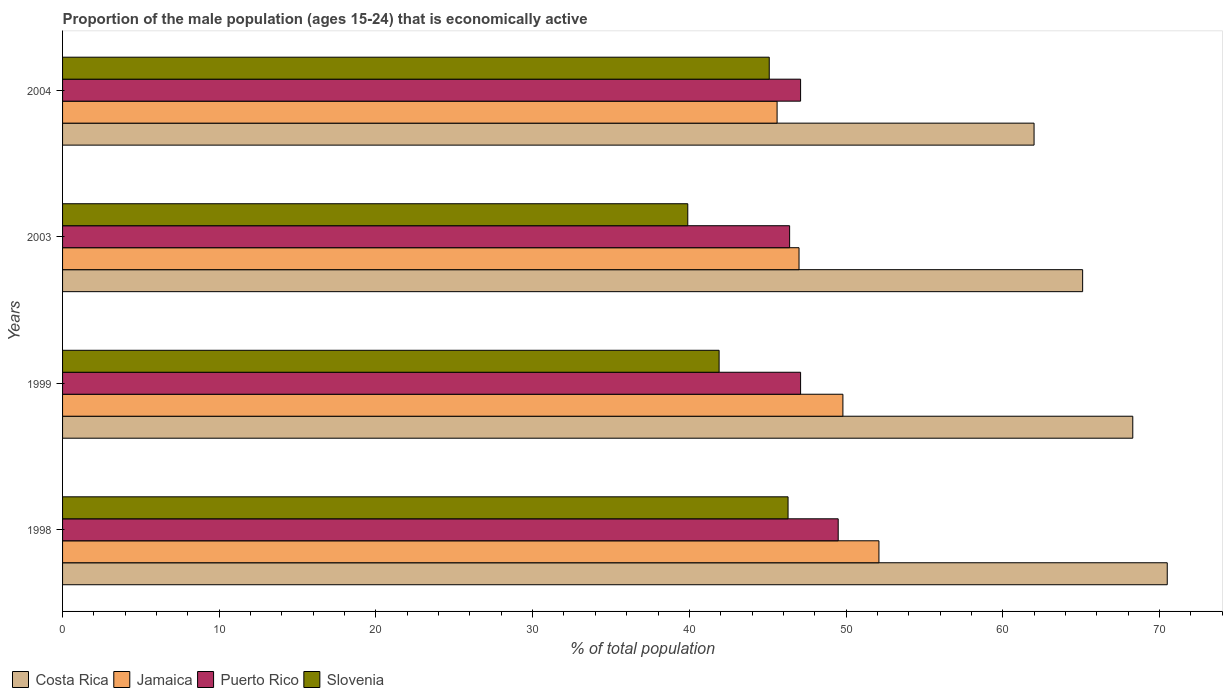How many different coloured bars are there?
Your answer should be compact. 4. How many groups of bars are there?
Provide a succinct answer. 4. Are the number of bars on each tick of the Y-axis equal?
Your answer should be very brief. Yes. How many bars are there on the 4th tick from the top?
Provide a short and direct response. 4. How many bars are there on the 1st tick from the bottom?
Offer a terse response. 4. What is the label of the 4th group of bars from the top?
Give a very brief answer. 1998. Across all years, what is the maximum proportion of the male population that is economically active in Slovenia?
Make the answer very short. 46.3. Across all years, what is the minimum proportion of the male population that is economically active in Puerto Rico?
Ensure brevity in your answer.  46.4. What is the total proportion of the male population that is economically active in Slovenia in the graph?
Offer a very short reply. 173.2. What is the difference between the proportion of the male population that is economically active in Jamaica in 1998 and that in 2003?
Provide a short and direct response. 5.1. What is the difference between the proportion of the male population that is economically active in Jamaica in 1998 and the proportion of the male population that is economically active in Slovenia in 2003?
Your answer should be very brief. 12.2. What is the average proportion of the male population that is economically active in Jamaica per year?
Provide a succinct answer. 48.62. In the year 2003, what is the difference between the proportion of the male population that is economically active in Jamaica and proportion of the male population that is economically active in Puerto Rico?
Your answer should be very brief. 0.6. In how many years, is the proportion of the male population that is economically active in Puerto Rico greater than 68 %?
Provide a short and direct response. 0. What is the ratio of the proportion of the male population that is economically active in Costa Rica in 1999 to that in 2004?
Offer a terse response. 1.1. Is the difference between the proportion of the male population that is economically active in Jamaica in 2003 and 2004 greater than the difference between the proportion of the male population that is economically active in Puerto Rico in 2003 and 2004?
Give a very brief answer. Yes. What is the difference between the highest and the second highest proportion of the male population that is economically active in Jamaica?
Your answer should be very brief. 2.3. What is the difference between the highest and the lowest proportion of the male population that is economically active in Puerto Rico?
Your answer should be compact. 3.1. In how many years, is the proportion of the male population that is economically active in Slovenia greater than the average proportion of the male population that is economically active in Slovenia taken over all years?
Provide a succinct answer. 2. What does the 3rd bar from the top in 2004 represents?
Give a very brief answer. Jamaica. What does the 2nd bar from the bottom in 2003 represents?
Your answer should be compact. Jamaica. How many bars are there?
Keep it short and to the point. 16. Are all the bars in the graph horizontal?
Offer a terse response. Yes. Where does the legend appear in the graph?
Your answer should be very brief. Bottom left. How many legend labels are there?
Provide a succinct answer. 4. What is the title of the graph?
Offer a very short reply. Proportion of the male population (ages 15-24) that is economically active. Does "Nepal" appear as one of the legend labels in the graph?
Offer a very short reply. No. What is the label or title of the X-axis?
Provide a succinct answer. % of total population. What is the % of total population in Costa Rica in 1998?
Make the answer very short. 70.5. What is the % of total population in Jamaica in 1998?
Offer a very short reply. 52.1. What is the % of total population of Puerto Rico in 1998?
Keep it short and to the point. 49.5. What is the % of total population of Slovenia in 1998?
Ensure brevity in your answer.  46.3. What is the % of total population of Costa Rica in 1999?
Ensure brevity in your answer.  68.3. What is the % of total population in Jamaica in 1999?
Offer a terse response. 49.8. What is the % of total population of Puerto Rico in 1999?
Your answer should be very brief. 47.1. What is the % of total population of Slovenia in 1999?
Make the answer very short. 41.9. What is the % of total population in Costa Rica in 2003?
Provide a short and direct response. 65.1. What is the % of total population in Jamaica in 2003?
Offer a very short reply. 47. What is the % of total population in Puerto Rico in 2003?
Your answer should be very brief. 46.4. What is the % of total population of Slovenia in 2003?
Your response must be concise. 39.9. What is the % of total population of Costa Rica in 2004?
Your answer should be compact. 62. What is the % of total population of Jamaica in 2004?
Make the answer very short. 45.6. What is the % of total population of Puerto Rico in 2004?
Provide a short and direct response. 47.1. What is the % of total population of Slovenia in 2004?
Provide a short and direct response. 45.1. Across all years, what is the maximum % of total population of Costa Rica?
Offer a terse response. 70.5. Across all years, what is the maximum % of total population of Jamaica?
Give a very brief answer. 52.1. Across all years, what is the maximum % of total population of Puerto Rico?
Offer a terse response. 49.5. Across all years, what is the maximum % of total population of Slovenia?
Provide a succinct answer. 46.3. Across all years, what is the minimum % of total population in Jamaica?
Provide a succinct answer. 45.6. Across all years, what is the minimum % of total population of Puerto Rico?
Give a very brief answer. 46.4. Across all years, what is the minimum % of total population in Slovenia?
Provide a succinct answer. 39.9. What is the total % of total population in Costa Rica in the graph?
Offer a terse response. 265.9. What is the total % of total population in Jamaica in the graph?
Ensure brevity in your answer.  194.5. What is the total % of total population in Puerto Rico in the graph?
Your answer should be compact. 190.1. What is the total % of total population in Slovenia in the graph?
Provide a short and direct response. 173.2. What is the difference between the % of total population in Puerto Rico in 1998 and that in 1999?
Your response must be concise. 2.4. What is the difference between the % of total population in Slovenia in 1998 and that in 1999?
Your answer should be compact. 4.4. What is the difference between the % of total population of Slovenia in 1998 and that in 2003?
Make the answer very short. 6.4. What is the difference between the % of total population of Costa Rica in 1998 and that in 2004?
Your answer should be compact. 8.5. What is the difference between the % of total population of Jamaica in 1999 and that in 2003?
Your response must be concise. 2.8. What is the difference between the % of total population of Jamaica in 1999 and that in 2004?
Offer a very short reply. 4.2. What is the difference between the % of total population in Puerto Rico in 1999 and that in 2004?
Keep it short and to the point. 0. What is the difference between the % of total population of Slovenia in 1999 and that in 2004?
Ensure brevity in your answer.  -3.2. What is the difference between the % of total population in Jamaica in 2003 and that in 2004?
Your response must be concise. 1.4. What is the difference between the % of total population of Puerto Rico in 2003 and that in 2004?
Keep it short and to the point. -0.7. What is the difference between the % of total population in Slovenia in 2003 and that in 2004?
Your answer should be very brief. -5.2. What is the difference between the % of total population of Costa Rica in 1998 and the % of total population of Jamaica in 1999?
Provide a short and direct response. 20.7. What is the difference between the % of total population of Costa Rica in 1998 and the % of total population of Puerto Rico in 1999?
Your answer should be very brief. 23.4. What is the difference between the % of total population in Costa Rica in 1998 and the % of total population in Slovenia in 1999?
Your response must be concise. 28.6. What is the difference between the % of total population of Jamaica in 1998 and the % of total population of Puerto Rico in 1999?
Offer a very short reply. 5. What is the difference between the % of total population in Puerto Rico in 1998 and the % of total population in Slovenia in 1999?
Provide a succinct answer. 7.6. What is the difference between the % of total population in Costa Rica in 1998 and the % of total population in Puerto Rico in 2003?
Your response must be concise. 24.1. What is the difference between the % of total population of Costa Rica in 1998 and the % of total population of Slovenia in 2003?
Offer a terse response. 30.6. What is the difference between the % of total population of Puerto Rico in 1998 and the % of total population of Slovenia in 2003?
Offer a very short reply. 9.6. What is the difference between the % of total population in Costa Rica in 1998 and the % of total population in Jamaica in 2004?
Provide a succinct answer. 24.9. What is the difference between the % of total population in Costa Rica in 1998 and the % of total population in Puerto Rico in 2004?
Offer a terse response. 23.4. What is the difference between the % of total population in Costa Rica in 1998 and the % of total population in Slovenia in 2004?
Offer a terse response. 25.4. What is the difference between the % of total population of Jamaica in 1998 and the % of total population of Puerto Rico in 2004?
Offer a terse response. 5. What is the difference between the % of total population of Jamaica in 1998 and the % of total population of Slovenia in 2004?
Give a very brief answer. 7. What is the difference between the % of total population of Costa Rica in 1999 and the % of total population of Jamaica in 2003?
Your answer should be compact. 21.3. What is the difference between the % of total population of Costa Rica in 1999 and the % of total population of Puerto Rico in 2003?
Your answer should be compact. 21.9. What is the difference between the % of total population of Costa Rica in 1999 and the % of total population of Slovenia in 2003?
Provide a short and direct response. 28.4. What is the difference between the % of total population in Jamaica in 1999 and the % of total population in Slovenia in 2003?
Keep it short and to the point. 9.9. What is the difference between the % of total population in Puerto Rico in 1999 and the % of total population in Slovenia in 2003?
Your answer should be compact. 7.2. What is the difference between the % of total population of Costa Rica in 1999 and the % of total population of Jamaica in 2004?
Offer a terse response. 22.7. What is the difference between the % of total population of Costa Rica in 1999 and the % of total population of Puerto Rico in 2004?
Offer a terse response. 21.2. What is the difference between the % of total population in Costa Rica in 1999 and the % of total population in Slovenia in 2004?
Offer a very short reply. 23.2. What is the difference between the % of total population in Jamaica in 1999 and the % of total population in Puerto Rico in 2004?
Your answer should be compact. 2.7. What is the difference between the % of total population in Costa Rica in 2003 and the % of total population in Jamaica in 2004?
Offer a very short reply. 19.5. What is the difference between the % of total population of Jamaica in 2003 and the % of total population of Puerto Rico in 2004?
Make the answer very short. -0.1. What is the difference between the % of total population in Jamaica in 2003 and the % of total population in Slovenia in 2004?
Your response must be concise. 1.9. What is the average % of total population in Costa Rica per year?
Offer a very short reply. 66.47. What is the average % of total population in Jamaica per year?
Give a very brief answer. 48.62. What is the average % of total population of Puerto Rico per year?
Offer a terse response. 47.52. What is the average % of total population in Slovenia per year?
Give a very brief answer. 43.3. In the year 1998, what is the difference between the % of total population of Costa Rica and % of total population of Puerto Rico?
Your answer should be very brief. 21. In the year 1998, what is the difference between the % of total population in Costa Rica and % of total population in Slovenia?
Your answer should be compact. 24.2. In the year 1998, what is the difference between the % of total population in Jamaica and % of total population in Slovenia?
Offer a very short reply. 5.8. In the year 1998, what is the difference between the % of total population in Puerto Rico and % of total population in Slovenia?
Keep it short and to the point. 3.2. In the year 1999, what is the difference between the % of total population in Costa Rica and % of total population in Jamaica?
Provide a short and direct response. 18.5. In the year 1999, what is the difference between the % of total population in Costa Rica and % of total population in Puerto Rico?
Your answer should be compact. 21.2. In the year 1999, what is the difference between the % of total population in Costa Rica and % of total population in Slovenia?
Give a very brief answer. 26.4. In the year 1999, what is the difference between the % of total population of Jamaica and % of total population of Puerto Rico?
Make the answer very short. 2.7. In the year 1999, what is the difference between the % of total population in Jamaica and % of total population in Slovenia?
Make the answer very short. 7.9. In the year 1999, what is the difference between the % of total population of Puerto Rico and % of total population of Slovenia?
Provide a succinct answer. 5.2. In the year 2003, what is the difference between the % of total population of Costa Rica and % of total population of Jamaica?
Keep it short and to the point. 18.1. In the year 2003, what is the difference between the % of total population of Costa Rica and % of total population of Puerto Rico?
Provide a succinct answer. 18.7. In the year 2003, what is the difference between the % of total population of Costa Rica and % of total population of Slovenia?
Your answer should be compact. 25.2. In the year 2003, what is the difference between the % of total population of Puerto Rico and % of total population of Slovenia?
Offer a terse response. 6.5. In the year 2004, what is the difference between the % of total population in Costa Rica and % of total population in Jamaica?
Your answer should be very brief. 16.4. In the year 2004, what is the difference between the % of total population of Costa Rica and % of total population of Slovenia?
Give a very brief answer. 16.9. In the year 2004, what is the difference between the % of total population of Jamaica and % of total population of Puerto Rico?
Give a very brief answer. -1.5. What is the ratio of the % of total population in Costa Rica in 1998 to that in 1999?
Keep it short and to the point. 1.03. What is the ratio of the % of total population in Jamaica in 1998 to that in 1999?
Offer a terse response. 1.05. What is the ratio of the % of total population in Puerto Rico in 1998 to that in 1999?
Your answer should be very brief. 1.05. What is the ratio of the % of total population of Slovenia in 1998 to that in 1999?
Offer a terse response. 1.1. What is the ratio of the % of total population of Costa Rica in 1998 to that in 2003?
Offer a terse response. 1.08. What is the ratio of the % of total population of Jamaica in 1998 to that in 2003?
Your answer should be compact. 1.11. What is the ratio of the % of total population of Puerto Rico in 1998 to that in 2003?
Your response must be concise. 1.07. What is the ratio of the % of total population of Slovenia in 1998 to that in 2003?
Make the answer very short. 1.16. What is the ratio of the % of total population in Costa Rica in 1998 to that in 2004?
Make the answer very short. 1.14. What is the ratio of the % of total population in Jamaica in 1998 to that in 2004?
Ensure brevity in your answer.  1.14. What is the ratio of the % of total population in Puerto Rico in 1998 to that in 2004?
Keep it short and to the point. 1.05. What is the ratio of the % of total population in Slovenia in 1998 to that in 2004?
Your answer should be very brief. 1.03. What is the ratio of the % of total population of Costa Rica in 1999 to that in 2003?
Offer a terse response. 1.05. What is the ratio of the % of total population of Jamaica in 1999 to that in 2003?
Your answer should be very brief. 1.06. What is the ratio of the % of total population in Puerto Rico in 1999 to that in 2003?
Offer a very short reply. 1.02. What is the ratio of the % of total population in Slovenia in 1999 to that in 2003?
Keep it short and to the point. 1.05. What is the ratio of the % of total population of Costa Rica in 1999 to that in 2004?
Provide a succinct answer. 1.1. What is the ratio of the % of total population of Jamaica in 1999 to that in 2004?
Your response must be concise. 1.09. What is the ratio of the % of total population of Puerto Rico in 1999 to that in 2004?
Provide a succinct answer. 1. What is the ratio of the % of total population of Slovenia in 1999 to that in 2004?
Provide a succinct answer. 0.93. What is the ratio of the % of total population in Costa Rica in 2003 to that in 2004?
Give a very brief answer. 1.05. What is the ratio of the % of total population of Jamaica in 2003 to that in 2004?
Provide a short and direct response. 1.03. What is the ratio of the % of total population in Puerto Rico in 2003 to that in 2004?
Provide a succinct answer. 0.99. What is the ratio of the % of total population of Slovenia in 2003 to that in 2004?
Give a very brief answer. 0.88. What is the difference between the highest and the lowest % of total population in Puerto Rico?
Provide a short and direct response. 3.1. What is the difference between the highest and the lowest % of total population in Slovenia?
Make the answer very short. 6.4. 